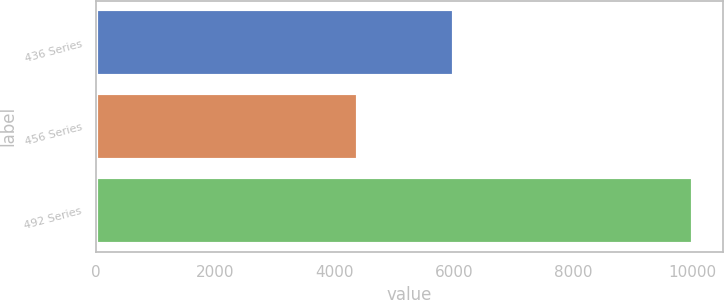Convert chart to OTSL. <chart><loc_0><loc_0><loc_500><loc_500><bar_chart><fcel>436 Series<fcel>456 Series<fcel>492 Series<nl><fcel>5992<fcel>4389<fcel>10000<nl></chart> 